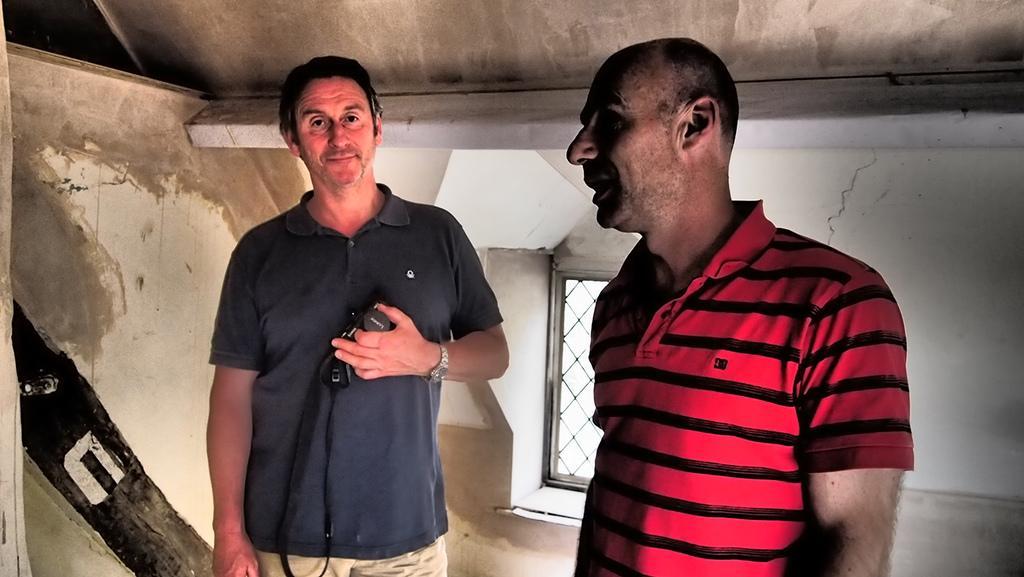Describe this image in one or two sentences. The man in the red T-shirt is standing and he is trying to talk something. Beside him, we see a man in the black T-shirt is standing and he is holding a camera in his hand. He is posing for the photo. Behind him, we see a wall. In the background, we see a white wall and a window. At the top, we see the roof of the building. 